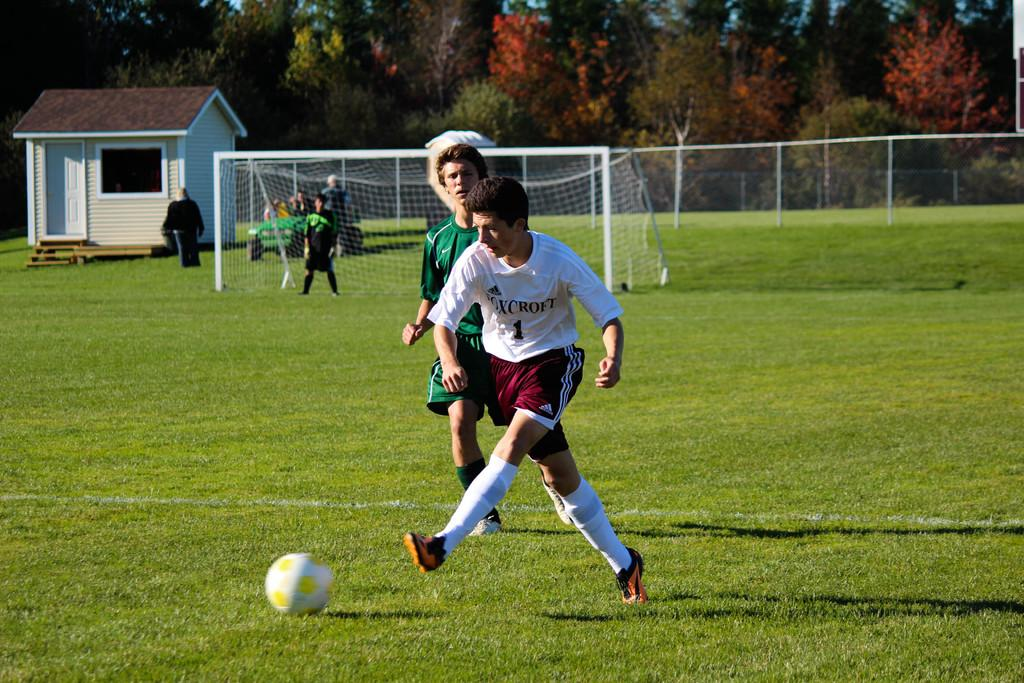What are the people in the image doing? The people in the image are playing. Where are the people playing? The people are playing on a ground. What can be seen in the background of the image? In the background of the image, there is a fence, a house, trees, stands, and people. What type of sack is being used by the people in the image? There is no sack visible in the image; the people are playing without any sacks. What sign is present in the image to indicate the rules of the game? There is no sign present in the image to indicate the rules of the game. 